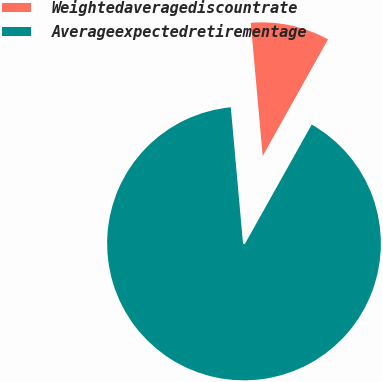Convert chart. <chart><loc_0><loc_0><loc_500><loc_500><pie_chart><fcel>Weightedaveragediscountrate<fcel>Averageexpectedretirementage<nl><fcel>9.55%<fcel>90.45%<nl></chart> 